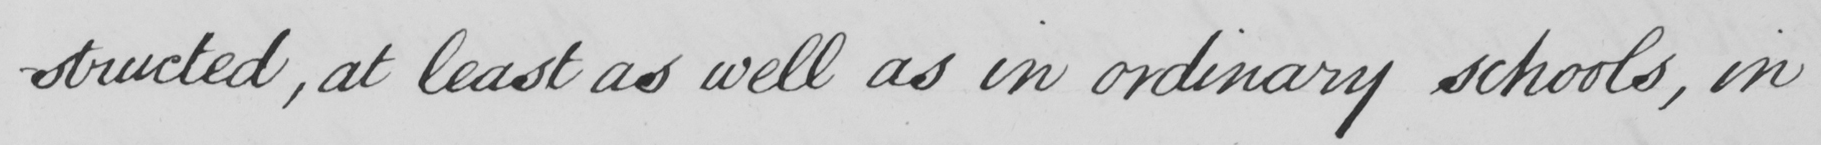What text is written in this handwritten line? -structed , at least as well as in ordinary schools , in 